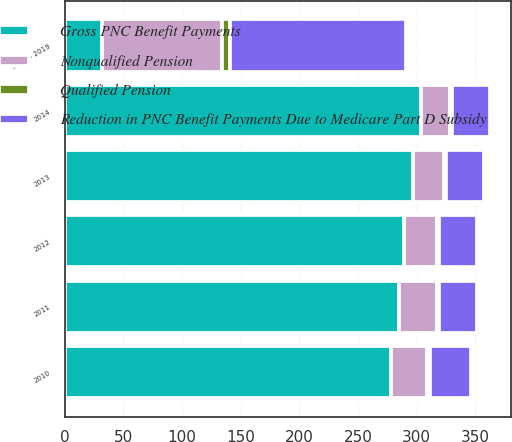Convert chart to OTSL. <chart><loc_0><loc_0><loc_500><loc_500><stacked_bar_chart><ecel><fcel>2010<fcel>2011<fcel>2012<fcel>2013<fcel>2014<fcel>2015 - 2019<nl><fcel>Gross PNC Benefit Payments<fcel>278<fcel>285<fcel>289<fcel>297<fcel>304<fcel>32<nl><fcel>Nonqualified Pension<fcel>31<fcel>32<fcel>28<fcel>26<fcel>24<fcel>102<nl><fcel>Reduction in PNC Benefit Payments Due to Medicare Part D Subsidy<fcel>35<fcel>32<fcel>32<fcel>32<fcel>32<fcel>150<nl><fcel>Qualified Pension<fcel>2<fcel>2<fcel>2<fcel>2<fcel>2<fcel>7<nl></chart> 